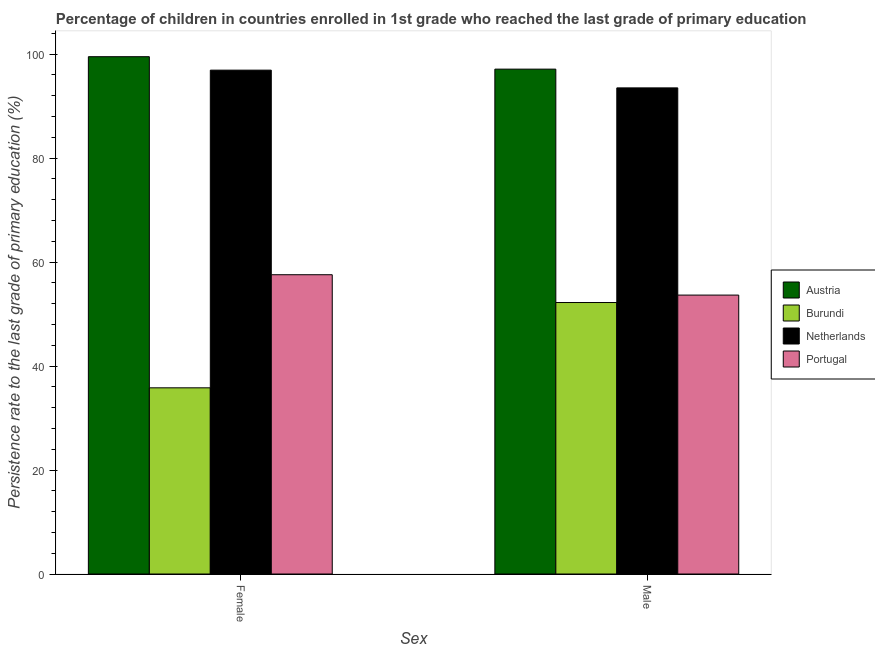Are the number of bars on each tick of the X-axis equal?
Your answer should be very brief. Yes. How many bars are there on the 2nd tick from the left?
Provide a succinct answer. 4. How many bars are there on the 1st tick from the right?
Make the answer very short. 4. What is the label of the 2nd group of bars from the left?
Offer a terse response. Male. What is the persistence rate of female students in Burundi?
Offer a very short reply. 35.81. Across all countries, what is the maximum persistence rate of male students?
Ensure brevity in your answer.  97.1. Across all countries, what is the minimum persistence rate of female students?
Provide a short and direct response. 35.81. In which country was the persistence rate of male students maximum?
Make the answer very short. Austria. In which country was the persistence rate of male students minimum?
Provide a succinct answer. Burundi. What is the total persistence rate of female students in the graph?
Offer a terse response. 289.76. What is the difference between the persistence rate of female students in Austria and that in Netherlands?
Offer a terse response. 2.59. What is the difference between the persistence rate of female students in Portugal and the persistence rate of male students in Austria?
Make the answer very short. -39.54. What is the average persistence rate of male students per country?
Offer a terse response. 74.11. What is the difference between the persistence rate of male students and persistence rate of female students in Burundi?
Keep it short and to the point. 16.4. In how many countries, is the persistence rate of female students greater than 60 %?
Provide a short and direct response. 2. What is the ratio of the persistence rate of male students in Austria to that in Portugal?
Give a very brief answer. 1.81. Is the persistence rate of female students in Burundi less than that in Austria?
Your answer should be very brief. Yes. How many bars are there?
Keep it short and to the point. 8. Are all the bars in the graph horizontal?
Your answer should be very brief. No. What is the difference between two consecutive major ticks on the Y-axis?
Your answer should be very brief. 20. What is the title of the graph?
Keep it short and to the point. Percentage of children in countries enrolled in 1st grade who reached the last grade of primary education. What is the label or title of the X-axis?
Your answer should be compact. Sex. What is the label or title of the Y-axis?
Keep it short and to the point. Persistence rate to the last grade of primary education (%). What is the Persistence rate to the last grade of primary education (%) in Austria in Female?
Provide a succinct answer. 99.49. What is the Persistence rate to the last grade of primary education (%) of Burundi in Female?
Keep it short and to the point. 35.81. What is the Persistence rate to the last grade of primary education (%) in Netherlands in Female?
Offer a terse response. 96.9. What is the Persistence rate to the last grade of primary education (%) in Portugal in Female?
Your answer should be compact. 57.56. What is the Persistence rate to the last grade of primary education (%) in Austria in Male?
Offer a terse response. 97.1. What is the Persistence rate to the last grade of primary education (%) of Burundi in Male?
Your response must be concise. 52.21. What is the Persistence rate to the last grade of primary education (%) in Netherlands in Male?
Keep it short and to the point. 93.49. What is the Persistence rate to the last grade of primary education (%) of Portugal in Male?
Your answer should be very brief. 53.64. Across all Sex, what is the maximum Persistence rate to the last grade of primary education (%) of Austria?
Your answer should be very brief. 99.49. Across all Sex, what is the maximum Persistence rate to the last grade of primary education (%) in Burundi?
Offer a very short reply. 52.21. Across all Sex, what is the maximum Persistence rate to the last grade of primary education (%) of Netherlands?
Offer a very short reply. 96.9. Across all Sex, what is the maximum Persistence rate to the last grade of primary education (%) of Portugal?
Offer a very short reply. 57.56. Across all Sex, what is the minimum Persistence rate to the last grade of primary education (%) of Austria?
Offer a very short reply. 97.1. Across all Sex, what is the minimum Persistence rate to the last grade of primary education (%) of Burundi?
Give a very brief answer. 35.81. Across all Sex, what is the minimum Persistence rate to the last grade of primary education (%) of Netherlands?
Your response must be concise. 93.49. Across all Sex, what is the minimum Persistence rate to the last grade of primary education (%) of Portugal?
Your answer should be compact. 53.64. What is the total Persistence rate to the last grade of primary education (%) of Austria in the graph?
Your response must be concise. 196.59. What is the total Persistence rate to the last grade of primary education (%) of Burundi in the graph?
Ensure brevity in your answer.  88.02. What is the total Persistence rate to the last grade of primary education (%) of Netherlands in the graph?
Your response must be concise. 190.4. What is the total Persistence rate to the last grade of primary education (%) in Portugal in the graph?
Your answer should be very brief. 111.2. What is the difference between the Persistence rate to the last grade of primary education (%) of Austria in Female and that in Male?
Your response must be concise. 2.39. What is the difference between the Persistence rate to the last grade of primary education (%) of Burundi in Female and that in Male?
Offer a terse response. -16.4. What is the difference between the Persistence rate to the last grade of primary education (%) in Netherlands in Female and that in Male?
Make the answer very short. 3.41. What is the difference between the Persistence rate to the last grade of primary education (%) of Portugal in Female and that in Male?
Make the answer very short. 3.92. What is the difference between the Persistence rate to the last grade of primary education (%) of Austria in Female and the Persistence rate to the last grade of primary education (%) of Burundi in Male?
Keep it short and to the point. 47.28. What is the difference between the Persistence rate to the last grade of primary education (%) of Austria in Female and the Persistence rate to the last grade of primary education (%) of Netherlands in Male?
Offer a terse response. 6. What is the difference between the Persistence rate to the last grade of primary education (%) in Austria in Female and the Persistence rate to the last grade of primary education (%) in Portugal in Male?
Offer a terse response. 45.85. What is the difference between the Persistence rate to the last grade of primary education (%) in Burundi in Female and the Persistence rate to the last grade of primary education (%) in Netherlands in Male?
Keep it short and to the point. -57.68. What is the difference between the Persistence rate to the last grade of primary education (%) in Burundi in Female and the Persistence rate to the last grade of primary education (%) in Portugal in Male?
Give a very brief answer. -17.83. What is the difference between the Persistence rate to the last grade of primary education (%) of Netherlands in Female and the Persistence rate to the last grade of primary education (%) of Portugal in Male?
Keep it short and to the point. 43.26. What is the average Persistence rate to the last grade of primary education (%) in Austria per Sex?
Ensure brevity in your answer.  98.3. What is the average Persistence rate to the last grade of primary education (%) in Burundi per Sex?
Offer a very short reply. 44.01. What is the average Persistence rate to the last grade of primary education (%) of Netherlands per Sex?
Ensure brevity in your answer.  95.2. What is the average Persistence rate to the last grade of primary education (%) of Portugal per Sex?
Provide a short and direct response. 55.6. What is the difference between the Persistence rate to the last grade of primary education (%) in Austria and Persistence rate to the last grade of primary education (%) in Burundi in Female?
Ensure brevity in your answer.  63.68. What is the difference between the Persistence rate to the last grade of primary education (%) in Austria and Persistence rate to the last grade of primary education (%) in Netherlands in Female?
Your answer should be very brief. 2.59. What is the difference between the Persistence rate to the last grade of primary education (%) in Austria and Persistence rate to the last grade of primary education (%) in Portugal in Female?
Ensure brevity in your answer.  41.93. What is the difference between the Persistence rate to the last grade of primary education (%) in Burundi and Persistence rate to the last grade of primary education (%) in Netherlands in Female?
Offer a terse response. -61.09. What is the difference between the Persistence rate to the last grade of primary education (%) in Burundi and Persistence rate to the last grade of primary education (%) in Portugal in Female?
Provide a short and direct response. -21.75. What is the difference between the Persistence rate to the last grade of primary education (%) in Netherlands and Persistence rate to the last grade of primary education (%) in Portugal in Female?
Offer a very short reply. 39.34. What is the difference between the Persistence rate to the last grade of primary education (%) in Austria and Persistence rate to the last grade of primary education (%) in Burundi in Male?
Your answer should be compact. 44.89. What is the difference between the Persistence rate to the last grade of primary education (%) of Austria and Persistence rate to the last grade of primary education (%) of Netherlands in Male?
Ensure brevity in your answer.  3.61. What is the difference between the Persistence rate to the last grade of primary education (%) of Austria and Persistence rate to the last grade of primary education (%) of Portugal in Male?
Your response must be concise. 43.46. What is the difference between the Persistence rate to the last grade of primary education (%) of Burundi and Persistence rate to the last grade of primary education (%) of Netherlands in Male?
Offer a terse response. -41.28. What is the difference between the Persistence rate to the last grade of primary education (%) of Burundi and Persistence rate to the last grade of primary education (%) of Portugal in Male?
Offer a terse response. -1.43. What is the difference between the Persistence rate to the last grade of primary education (%) in Netherlands and Persistence rate to the last grade of primary education (%) in Portugal in Male?
Keep it short and to the point. 39.85. What is the ratio of the Persistence rate to the last grade of primary education (%) in Austria in Female to that in Male?
Offer a terse response. 1.02. What is the ratio of the Persistence rate to the last grade of primary education (%) in Burundi in Female to that in Male?
Offer a very short reply. 0.69. What is the ratio of the Persistence rate to the last grade of primary education (%) in Netherlands in Female to that in Male?
Your answer should be compact. 1.04. What is the ratio of the Persistence rate to the last grade of primary education (%) in Portugal in Female to that in Male?
Your response must be concise. 1.07. What is the difference between the highest and the second highest Persistence rate to the last grade of primary education (%) in Austria?
Your response must be concise. 2.39. What is the difference between the highest and the second highest Persistence rate to the last grade of primary education (%) in Burundi?
Provide a succinct answer. 16.4. What is the difference between the highest and the second highest Persistence rate to the last grade of primary education (%) of Netherlands?
Provide a succinct answer. 3.41. What is the difference between the highest and the second highest Persistence rate to the last grade of primary education (%) of Portugal?
Provide a succinct answer. 3.92. What is the difference between the highest and the lowest Persistence rate to the last grade of primary education (%) of Austria?
Keep it short and to the point. 2.39. What is the difference between the highest and the lowest Persistence rate to the last grade of primary education (%) of Burundi?
Your response must be concise. 16.4. What is the difference between the highest and the lowest Persistence rate to the last grade of primary education (%) in Netherlands?
Make the answer very short. 3.41. What is the difference between the highest and the lowest Persistence rate to the last grade of primary education (%) of Portugal?
Offer a very short reply. 3.92. 